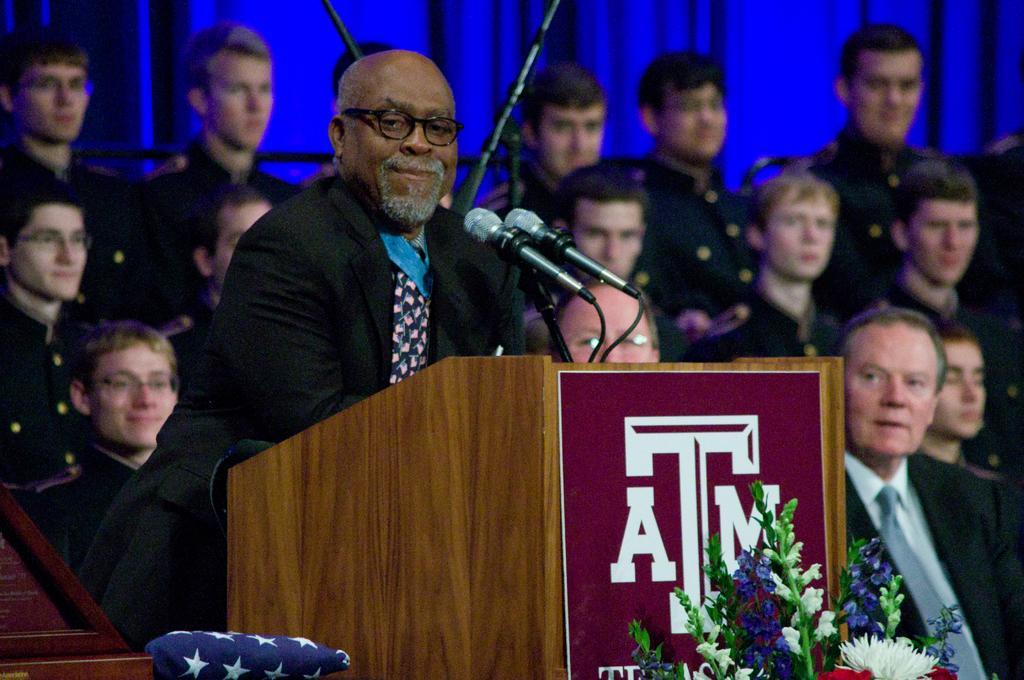Could you give a brief overview of what you see in this image? In this image we can see many people. A person is standing near the podium. There is a microphone and a bouquet in the image. 